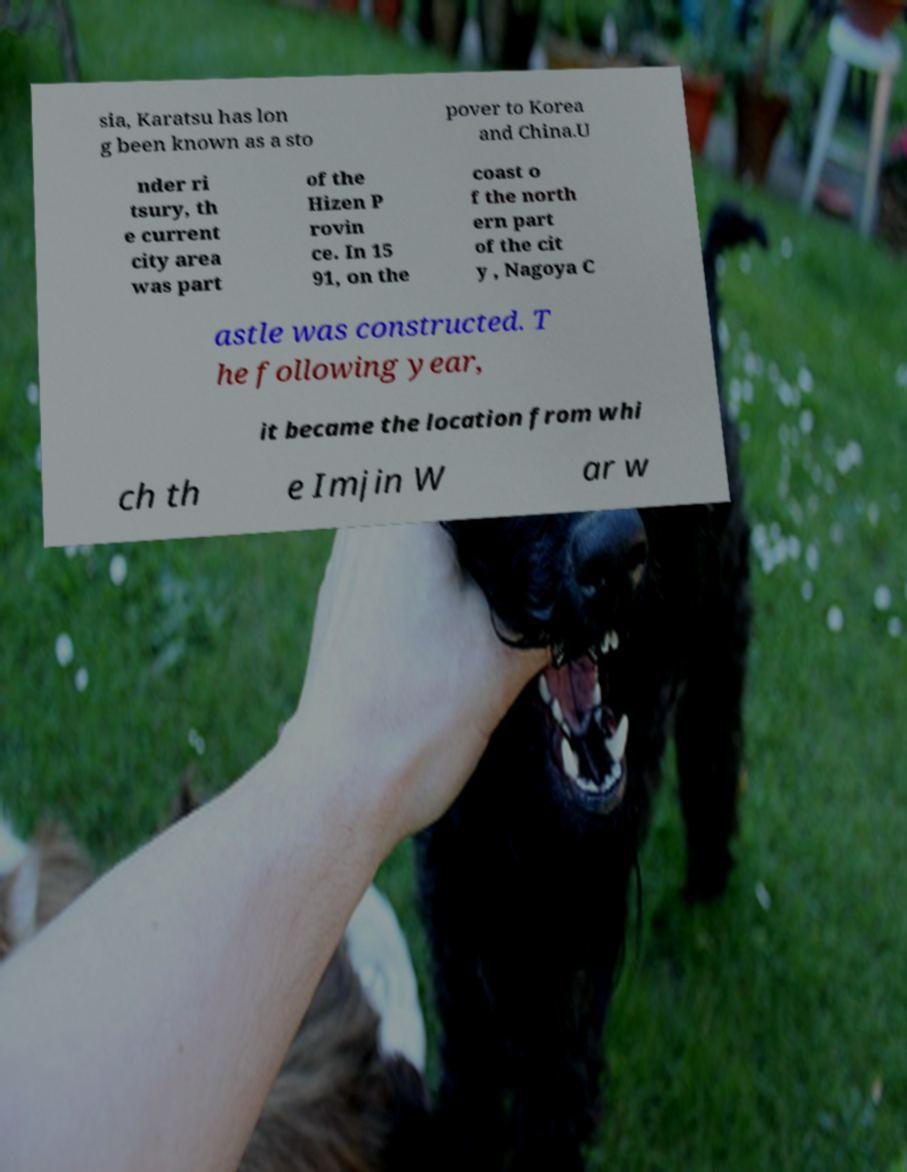Could you assist in decoding the text presented in this image and type it out clearly? sia, Karatsu has lon g been known as a sto pover to Korea and China.U nder ri tsury, th e current city area was part of the Hizen P rovin ce. In 15 91, on the coast o f the north ern part of the cit y , Nagoya C astle was constructed. T he following year, it became the location from whi ch th e Imjin W ar w 